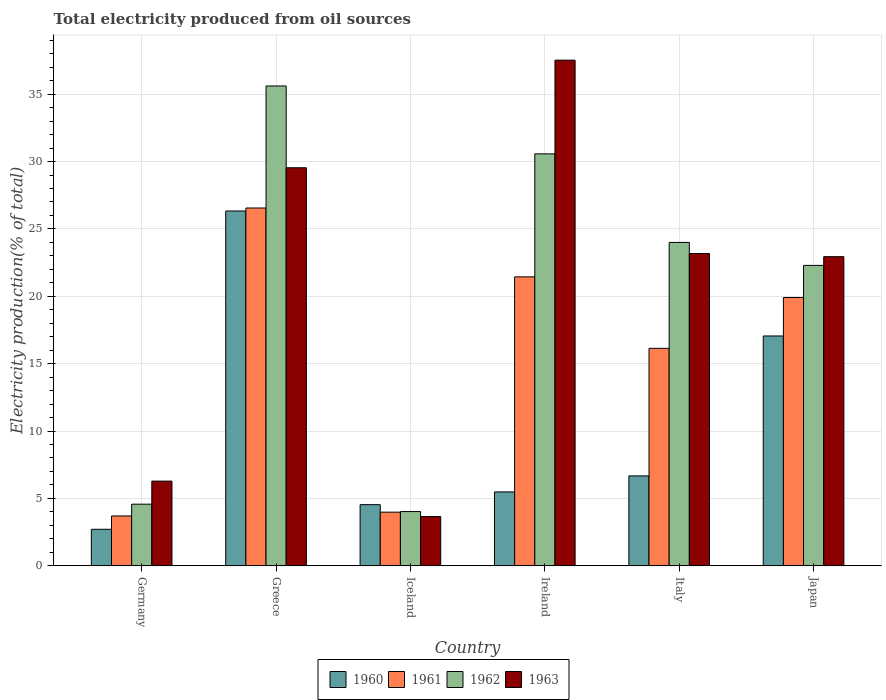How many different coloured bars are there?
Offer a very short reply. 4. How many bars are there on the 4th tick from the left?
Offer a very short reply. 4. How many bars are there on the 5th tick from the right?
Offer a very short reply. 4. What is the total electricity produced in 1960 in Italy?
Give a very brief answer. 6.67. Across all countries, what is the maximum total electricity produced in 1963?
Your answer should be very brief. 37.53. Across all countries, what is the minimum total electricity produced in 1962?
Make the answer very short. 4.03. In which country was the total electricity produced in 1963 maximum?
Provide a succinct answer. Ireland. In which country was the total electricity produced in 1961 minimum?
Offer a terse response. Germany. What is the total total electricity produced in 1960 in the graph?
Offer a terse response. 62.79. What is the difference between the total electricity produced in 1961 in Ireland and that in Italy?
Your answer should be compact. 5.3. What is the difference between the total electricity produced in 1962 in Japan and the total electricity produced in 1963 in Greece?
Ensure brevity in your answer.  -7.25. What is the average total electricity produced in 1962 per country?
Your answer should be compact. 20.18. What is the difference between the total electricity produced of/in 1960 and total electricity produced of/in 1961 in Iceland?
Ensure brevity in your answer.  0.56. In how many countries, is the total electricity produced in 1961 greater than 15 %?
Offer a terse response. 4. What is the ratio of the total electricity produced in 1961 in Greece to that in Iceland?
Give a very brief answer. 6.67. Is the total electricity produced in 1960 in Germany less than that in Iceland?
Offer a very short reply. Yes. Is the difference between the total electricity produced in 1960 in Ireland and Italy greater than the difference between the total electricity produced in 1961 in Ireland and Italy?
Your answer should be very brief. No. What is the difference between the highest and the second highest total electricity produced in 1961?
Your answer should be very brief. 6.64. What is the difference between the highest and the lowest total electricity produced in 1960?
Your answer should be compact. 23.62. What does the 1st bar from the right in Greece represents?
Keep it short and to the point. 1963. Is it the case that in every country, the sum of the total electricity produced in 1960 and total electricity produced in 1961 is greater than the total electricity produced in 1963?
Offer a terse response. No. How many bars are there?
Give a very brief answer. 24. Are all the bars in the graph horizontal?
Make the answer very short. No. Are the values on the major ticks of Y-axis written in scientific E-notation?
Your answer should be compact. No. Does the graph contain any zero values?
Your response must be concise. No. Where does the legend appear in the graph?
Offer a terse response. Bottom center. How many legend labels are there?
Your response must be concise. 4. How are the legend labels stacked?
Your answer should be very brief. Horizontal. What is the title of the graph?
Offer a terse response. Total electricity produced from oil sources. Does "1994" appear as one of the legend labels in the graph?
Offer a very short reply. No. What is the label or title of the X-axis?
Your response must be concise. Country. What is the label or title of the Y-axis?
Your answer should be compact. Electricity production(% of total). What is the Electricity production(% of total) in 1960 in Germany?
Your answer should be compact. 2.71. What is the Electricity production(% of total) in 1961 in Germany?
Provide a short and direct response. 3.7. What is the Electricity production(% of total) in 1962 in Germany?
Offer a very short reply. 4.57. What is the Electricity production(% of total) in 1963 in Germany?
Your answer should be compact. 6.28. What is the Electricity production(% of total) in 1960 in Greece?
Provide a succinct answer. 26.33. What is the Electricity production(% of total) in 1961 in Greece?
Provide a succinct answer. 26.55. What is the Electricity production(% of total) in 1962 in Greece?
Ensure brevity in your answer.  35.61. What is the Electricity production(% of total) of 1963 in Greece?
Offer a terse response. 29.54. What is the Electricity production(% of total) in 1960 in Iceland?
Give a very brief answer. 4.54. What is the Electricity production(% of total) in 1961 in Iceland?
Provide a succinct answer. 3.98. What is the Electricity production(% of total) in 1962 in Iceland?
Provide a succinct answer. 4.03. What is the Electricity production(% of total) in 1963 in Iceland?
Give a very brief answer. 3.66. What is the Electricity production(% of total) of 1960 in Ireland?
Your response must be concise. 5.48. What is the Electricity production(% of total) in 1961 in Ireland?
Your answer should be compact. 21.44. What is the Electricity production(% of total) of 1962 in Ireland?
Make the answer very short. 30.57. What is the Electricity production(% of total) of 1963 in Ireland?
Offer a very short reply. 37.53. What is the Electricity production(% of total) in 1960 in Italy?
Keep it short and to the point. 6.67. What is the Electricity production(% of total) in 1961 in Italy?
Provide a succinct answer. 16.14. What is the Electricity production(% of total) in 1962 in Italy?
Provide a succinct answer. 24. What is the Electricity production(% of total) in 1963 in Italy?
Your answer should be compact. 23.17. What is the Electricity production(% of total) of 1960 in Japan?
Give a very brief answer. 17.06. What is the Electricity production(% of total) of 1961 in Japan?
Offer a terse response. 19.91. What is the Electricity production(% of total) in 1962 in Japan?
Offer a very short reply. 22.29. What is the Electricity production(% of total) in 1963 in Japan?
Your response must be concise. 22.94. Across all countries, what is the maximum Electricity production(% of total) of 1960?
Provide a succinct answer. 26.33. Across all countries, what is the maximum Electricity production(% of total) in 1961?
Your answer should be very brief. 26.55. Across all countries, what is the maximum Electricity production(% of total) in 1962?
Your answer should be compact. 35.61. Across all countries, what is the maximum Electricity production(% of total) of 1963?
Provide a short and direct response. 37.53. Across all countries, what is the minimum Electricity production(% of total) of 1960?
Your answer should be compact. 2.71. Across all countries, what is the minimum Electricity production(% of total) of 1961?
Offer a very short reply. 3.7. Across all countries, what is the minimum Electricity production(% of total) in 1962?
Your response must be concise. 4.03. Across all countries, what is the minimum Electricity production(% of total) in 1963?
Your answer should be compact. 3.66. What is the total Electricity production(% of total) in 1960 in the graph?
Your response must be concise. 62.79. What is the total Electricity production(% of total) of 1961 in the graph?
Provide a succinct answer. 91.72. What is the total Electricity production(% of total) in 1962 in the graph?
Offer a very short reply. 121.07. What is the total Electricity production(% of total) of 1963 in the graph?
Ensure brevity in your answer.  123.13. What is the difference between the Electricity production(% of total) in 1960 in Germany and that in Greece?
Keep it short and to the point. -23.62. What is the difference between the Electricity production(% of total) in 1961 in Germany and that in Greece?
Offer a terse response. -22.86. What is the difference between the Electricity production(% of total) in 1962 in Germany and that in Greece?
Offer a very short reply. -31.04. What is the difference between the Electricity production(% of total) of 1963 in Germany and that in Greece?
Your answer should be compact. -23.26. What is the difference between the Electricity production(% of total) of 1960 in Germany and that in Iceland?
Provide a succinct answer. -1.83. What is the difference between the Electricity production(% of total) in 1961 in Germany and that in Iceland?
Your answer should be very brief. -0.28. What is the difference between the Electricity production(% of total) in 1962 in Germany and that in Iceland?
Your answer should be compact. 0.55. What is the difference between the Electricity production(% of total) of 1963 in Germany and that in Iceland?
Offer a very short reply. 2.63. What is the difference between the Electricity production(% of total) in 1960 in Germany and that in Ireland?
Your response must be concise. -2.77. What is the difference between the Electricity production(% of total) of 1961 in Germany and that in Ireland?
Offer a terse response. -17.75. What is the difference between the Electricity production(% of total) in 1962 in Germany and that in Ireland?
Offer a very short reply. -26. What is the difference between the Electricity production(% of total) in 1963 in Germany and that in Ireland?
Keep it short and to the point. -31.24. What is the difference between the Electricity production(% of total) in 1960 in Germany and that in Italy?
Provide a succinct answer. -3.96. What is the difference between the Electricity production(% of total) of 1961 in Germany and that in Italy?
Offer a very short reply. -12.44. What is the difference between the Electricity production(% of total) of 1962 in Germany and that in Italy?
Keep it short and to the point. -19.43. What is the difference between the Electricity production(% of total) of 1963 in Germany and that in Italy?
Ensure brevity in your answer.  -16.89. What is the difference between the Electricity production(% of total) of 1960 in Germany and that in Japan?
Give a very brief answer. -14.35. What is the difference between the Electricity production(% of total) in 1961 in Germany and that in Japan?
Provide a succinct answer. -16.21. What is the difference between the Electricity production(% of total) in 1962 in Germany and that in Japan?
Provide a succinct answer. -17.72. What is the difference between the Electricity production(% of total) in 1963 in Germany and that in Japan?
Your answer should be very brief. -16.66. What is the difference between the Electricity production(% of total) in 1960 in Greece and that in Iceland?
Offer a very short reply. 21.79. What is the difference between the Electricity production(% of total) in 1961 in Greece and that in Iceland?
Your answer should be very brief. 22.57. What is the difference between the Electricity production(% of total) in 1962 in Greece and that in Iceland?
Provide a short and direct response. 31.58. What is the difference between the Electricity production(% of total) in 1963 in Greece and that in Iceland?
Provide a short and direct response. 25.88. What is the difference between the Electricity production(% of total) of 1960 in Greece and that in Ireland?
Ensure brevity in your answer.  20.85. What is the difference between the Electricity production(% of total) of 1961 in Greece and that in Ireland?
Offer a very short reply. 5.11. What is the difference between the Electricity production(% of total) of 1962 in Greece and that in Ireland?
Ensure brevity in your answer.  5.04. What is the difference between the Electricity production(% of total) of 1963 in Greece and that in Ireland?
Offer a very short reply. -7.99. What is the difference between the Electricity production(% of total) of 1960 in Greece and that in Italy?
Your answer should be compact. 19.66. What is the difference between the Electricity production(% of total) in 1961 in Greece and that in Italy?
Your response must be concise. 10.42. What is the difference between the Electricity production(% of total) of 1962 in Greece and that in Italy?
Your response must be concise. 11.61. What is the difference between the Electricity production(% of total) in 1963 in Greece and that in Italy?
Make the answer very short. 6.37. What is the difference between the Electricity production(% of total) in 1960 in Greece and that in Japan?
Your answer should be very brief. 9.28. What is the difference between the Electricity production(% of total) of 1961 in Greece and that in Japan?
Give a very brief answer. 6.64. What is the difference between the Electricity production(% of total) of 1962 in Greece and that in Japan?
Your answer should be compact. 13.32. What is the difference between the Electricity production(% of total) of 1963 in Greece and that in Japan?
Ensure brevity in your answer.  6.6. What is the difference between the Electricity production(% of total) in 1960 in Iceland and that in Ireland?
Provide a short and direct response. -0.94. What is the difference between the Electricity production(% of total) of 1961 in Iceland and that in Ireland?
Keep it short and to the point. -17.46. What is the difference between the Electricity production(% of total) in 1962 in Iceland and that in Ireland?
Ensure brevity in your answer.  -26.55. What is the difference between the Electricity production(% of total) in 1963 in Iceland and that in Ireland?
Ensure brevity in your answer.  -33.87. What is the difference between the Electricity production(% of total) in 1960 in Iceland and that in Italy?
Make the answer very short. -2.13. What is the difference between the Electricity production(% of total) in 1961 in Iceland and that in Italy?
Your response must be concise. -12.16. What is the difference between the Electricity production(% of total) of 1962 in Iceland and that in Italy?
Your response must be concise. -19.97. What is the difference between the Electricity production(% of total) of 1963 in Iceland and that in Italy?
Keep it short and to the point. -19.52. What is the difference between the Electricity production(% of total) in 1960 in Iceland and that in Japan?
Make the answer very short. -12.52. What is the difference between the Electricity production(% of total) of 1961 in Iceland and that in Japan?
Provide a succinct answer. -15.93. What is the difference between the Electricity production(% of total) of 1962 in Iceland and that in Japan?
Provide a short and direct response. -18.27. What is the difference between the Electricity production(% of total) in 1963 in Iceland and that in Japan?
Give a very brief answer. -19.28. What is the difference between the Electricity production(% of total) in 1960 in Ireland and that in Italy?
Provide a succinct answer. -1.19. What is the difference between the Electricity production(% of total) in 1961 in Ireland and that in Italy?
Keep it short and to the point. 5.3. What is the difference between the Electricity production(% of total) of 1962 in Ireland and that in Italy?
Offer a very short reply. 6.57. What is the difference between the Electricity production(% of total) in 1963 in Ireland and that in Italy?
Provide a short and direct response. 14.35. What is the difference between the Electricity production(% of total) in 1960 in Ireland and that in Japan?
Offer a terse response. -11.57. What is the difference between the Electricity production(% of total) in 1961 in Ireland and that in Japan?
Your response must be concise. 1.53. What is the difference between the Electricity production(% of total) of 1962 in Ireland and that in Japan?
Ensure brevity in your answer.  8.28. What is the difference between the Electricity production(% of total) in 1963 in Ireland and that in Japan?
Offer a terse response. 14.58. What is the difference between the Electricity production(% of total) in 1960 in Italy and that in Japan?
Your answer should be very brief. -10.39. What is the difference between the Electricity production(% of total) of 1961 in Italy and that in Japan?
Ensure brevity in your answer.  -3.77. What is the difference between the Electricity production(% of total) of 1962 in Italy and that in Japan?
Keep it short and to the point. 1.71. What is the difference between the Electricity production(% of total) in 1963 in Italy and that in Japan?
Offer a terse response. 0.23. What is the difference between the Electricity production(% of total) of 1960 in Germany and the Electricity production(% of total) of 1961 in Greece?
Offer a very short reply. -23.85. What is the difference between the Electricity production(% of total) in 1960 in Germany and the Electricity production(% of total) in 1962 in Greece?
Offer a terse response. -32.9. What is the difference between the Electricity production(% of total) in 1960 in Germany and the Electricity production(% of total) in 1963 in Greece?
Give a very brief answer. -26.83. What is the difference between the Electricity production(% of total) of 1961 in Germany and the Electricity production(% of total) of 1962 in Greece?
Provide a succinct answer. -31.91. What is the difference between the Electricity production(% of total) of 1961 in Germany and the Electricity production(% of total) of 1963 in Greece?
Give a very brief answer. -25.84. What is the difference between the Electricity production(% of total) of 1962 in Germany and the Electricity production(% of total) of 1963 in Greece?
Offer a very short reply. -24.97. What is the difference between the Electricity production(% of total) in 1960 in Germany and the Electricity production(% of total) in 1961 in Iceland?
Ensure brevity in your answer.  -1.27. What is the difference between the Electricity production(% of total) in 1960 in Germany and the Electricity production(% of total) in 1962 in Iceland?
Your answer should be compact. -1.32. What is the difference between the Electricity production(% of total) in 1960 in Germany and the Electricity production(% of total) in 1963 in Iceland?
Your response must be concise. -0.95. What is the difference between the Electricity production(% of total) of 1961 in Germany and the Electricity production(% of total) of 1962 in Iceland?
Offer a terse response. -0.33. What is the difference between the Electricity production(% of total) in 1961 in Germany and the Electricity production(% of total) in 1963 in Iceland?
Your answer should be compact. 0.04. What is the difference between the Electricity production(% of total) in 1962 in Germany and the Electricity production(% of total) in 1963 in Iceland?
Provide a succinct answer. 0.91. What is the difference between the Electricity production(% of total) of 1960 in Germany and the Electricity production(% of total) of 1961 in Ireland?
Ensure brevity in your answer.  -18.73. What is the difference between the Electricity production(% of total) in 1960 in Germany and the Electricity production(% of total) in 1962 in Ireland?
Provide a short and direct response. -27.86. What is the difference between the Electricity production(% of total) in 1960 in Germany and the Electricity production(% of total) in 1963 in Ireland?
Your response must be concise. -34.82. What is the difference between the Electricity production(% of total) of 1961 in Germany and the Electricity production(% of total) of 1962 in Ireland?
Your response must be concise. -26.87. What is the difference between the Electricity production(% of total) in 1961 in Germany and the Electricity production(% of total) in 1963 in Ireland?
Make the answer very short. -33.83. What is the difference between the Electricity production(% of total) of 1962 in Germany and the Electricity production(% of total) of 1963 in Ireland?
Keep it short and to the point. -32.95. What is the difference between the Electricity production(% of total) of 1960 in Germany and the Electricity production(% of total) of 1961 in Italy?
Provide a short and direct response. -13.43. What is the difference between the Electricity production(% of total) in 1960 in Germany and the Electricity production(% of total) in 1962 in Italy?
Offer a very short reply. -21.29. What is the difference between the Electricity production(% of total) in 1960 in Germany and the Electricity production(% of total) in 1963 in Italy?
Provide a short and direct response. -20.47. What is the difference between the Electricity production(% of total) of 1961 in Germany and the Electricity production(% of total) of 1962 in Italy?
Your answer should be very brief. -20.3. What is the difference between the Electricity production(% of total) of 1961 in Germany and the Electricity production(% of total) of 1963 in Italy?
Provide a short and direct response. -19.48. What is the difference between the Electricity production(% of total) in 1962 in Germany and the Electricity production(% of total) in 1963 in Italy?
Your response must be concise. -18.6. What is the difference between the Electricity production(% of total) of 1960 in Germany and the Electricity production(% of total) of 1961 in Japan?
Give a very brief answer. -17.2. What is the difference between the Electricity production(% of total) of 1960 in Germany and the Electricity production(% of total) of 1962 in Japan?
Your answer should be very brief. -19.58. What is the difference between the Electricity production(% of total) of 1960 in Germany and the Electricity production(% of total) of 1963 in Japan?
Offer a very short reply. -20.23. What is the difference between the Electricity production(% of total) in 1961 in Germany and the Electricity production(% of total) in 1962 in Japan?
Your answer should be very brief. -18.6. What is the difference between the Electricity production(% of total) in 1961 in Germany and the Electricity production(% of total) in 1963 in Japan?
Your response must be concise. -19.24. What is the difference between the Electricity production(% of total) in 1962 in Germany and the Electricity production(% of total) in 1963 in Japan?
Offer a very short reply. -18.37. What is the difference between the Electricity production(% of total) in 1960 in Greece and the Electricity production(% of total) in 1961 in Iceland?
Ensure brevity in your answer.  22.35. What is the difference between the Electricity production(% of total) in 1960 in Greece and the Electricity production(% of total) in 1962 in Iceland?
Your answer should be very brief. 22.31. What is the difference between the Electricity production(% of total) in 1960 in Greece and the Electricity production(% of total) in 1963 in Iceland?
Make the answer very short. 22.67. What is the difference between the Electricity production(% of total) in 1961 in Greece and the Electricity production(% of total) in 1962 in Iceland?
Keep it short and to the point. 22.53. What is the difference between the Electricity production(% of total) in 1961 in Greece and the Electricity production(% of total) in 1963 in Iceland?
Provide a short and direct response. 22.9. What is the difference between the Electricity production(% of total) in 1962 in Greece and the Electricity production(% of total) in 1963 in Iceland?
Your answer should be compact. 31.95. What is the difference between the Electricity production(% of total) of 1960 in Greece and the Electricity production(% of total) of 1961 in Ireland?
Offer a terse response. 4.89. What is the difference between the Electricity production(% of total) of 1960 in Greece and the Electricity production(% of total) of 1962 in Ireland?
Your answer should be compact. -4.24. What is the difference between the Electricity production(% of total) of 1960 in Greece and the Electricity production(% of total) of 1963 in Ireland?
Give a very brief answer. -11.19. What is the difference between the Electricity production(% of total) of 1961 in Greece and the Electricity production(% of total) of 1962 in Ireland?
Ensure brevity in your answer.  -4.02. What is the difference between the Electricity production(% of total) in 1961 in Greece and the Electricity production(% of total) in 1963 in Ireland?
Your answer should be very brief. -10.97. What is the difference between the Electricity production(% of total) in 1962 in Greece and the Electricity production(% of total) in 1963 in Ireland?
Your answer should be compact. -1.92. What is the difference between the Electricity production(% of total) in 1960 in Greece and the Electricity production(% of total) in 1961 in Italy?
Ensure brevity in your answer.  10.19. What is the difference between the Electricity production(% of total) in 1960 in Greece and the Electricity production(% of total) in 1962 in Italy?
Give a very brief answer. 2.33. What is the difference between the Electricity production(% of total) in 1960 in Greece and the Electricity production(% of total) in 1963 in Italy?
Keep it short and to the point. 3.16. What is the difference between the Electricity production(% of total) of 1961 in Greece and the Electricity production(% of total) of 1962 in Italy?
Offer a terse response. 2.55. What is the difference between the Electricity production(% of total) in 1961 in Greece and the Electricity production(% of total) in 1963 in Italy?
Your answer should be compact. 3.38. What is the difference between the Electricity production(% of total) of 1962 in Greece and the Electricity production(% of total) of 1963 in Italy?
Your answer should be compact. 12.44. What is the difference between the Electricity production(% of total) in 1960 in Greece and the Electricity production(% of total) in 1961 in Japan?
Ensure brevity in your answer.  6.42. What is the difference between the Electricity production(% of total) in 1960 in Greece and the Electricity production(% of total) in 1962 in Japan?
Make the answer very short. 4.04. What is the difference between the Electricity production(% of total) of 1960 in Greece and the Electricity production(% of total) of 1963 in Japan?
Make the answer very short. 3.39. What is the difference between the Electricity production(% of total) of 1961 in Greece and the Electricity production(% of total) of 1962 in Japan?
Provide a short and direct response. 4.26. What is the difference between the Electricity production(% of total) of 1961 in Greece and the Electricity production(% of total) of 1963 in Japan?
Your answer should be very brief. 3.61. What is the difference between the Electricity production(% of total) in 1962 in Greece and the Electricity production(% of total) in 1963 in Japan?
Ensure brevity in your answer.  12.67. What is the difference between the Electricity production(% of total) of 1960 in Iceland and the Electricity production(% of total) of 1961 in Ireland?
Provide a succinct answer. -16.91. What is the difference between the Electricity production(% of total) of 1960 in Iceland and the Electricity production(% of total) of 1962 in Ireland?
Keep it short and to the point. -26.03. What is the difference between the Electricity production(% of total) of 1960 in Iceland and the Electricity production(% of total) of 1963 in Ireland?
Provide a short and direct response. -32.99. What is the difference between the Electricity production(% of total) of 1961 in Iceland and the Electricity production(% of total) of 1962 in Ireland?
Provide a short and direct response. -26.59. What is the difference between the Electricity production(% of total) in 1961 in Iceland and the Electricity production(% of total) in 1963 in Ireland?
Offer a terse response. -33.55. What is the difference between the Electricity production(% of total) in 1962 in Iceland and the Electricity production(% of total) in 1963 in Ireland?
Your answer should be very brief. -33.5. What is the difference between the Electricity production(% of total) in 1960 in Iceland and the Electricity production(% of total) in 1961 in Italy?
Offer a very short reply. -11.6. What is the difference between the Electricity production(% of total) in 1960 in Iceland and the Electricity production(% of total) in 1962 in Italy?
Keep it short and to the point. -19.46. What is the difference between the Electricity production(% of total) of 1960 in Iceland and the Electricity production(% of total) of 1963 in Italy?
Offer a terse response. -18.64. What is the difference between the Electricity production(% of total) of 1961 in Iceland and the Electricity production(% of total) of 1962 in Italy?
Provide a succinct answer. -20.02. What is the difference between the Electricity production(% of total) of 1961 in Iceland and the Electricity production(% of total) of 1963 in Italy?
Offer a terse response. -19.19. What is the difference between the Electricity production(% of total) of 1962 in Iceland and the Electricity production(% of total) of 1963 in Italy?
Make the answer very short. -19.15. What is the difference between the Electricity production(% of total) in 1960 in Iceland and the Electricity production(% of total) in 1961 in Japan?
Provide a short and direct response. -15.37. What is the difference between the Electricity production(% of total) in 1960 in Iceland and the Electricity production(% of total) in 1962 in Japan?
Ensure brevity in your answer.  -17.76. What is the difference between the Electricity production(% of total) in 1960 in Iceland and the Electricity production(% of total) in 1963 in Japan?
Provide a short and direct response. -18.4. What is the difference between the Electricity production(% of total) in 1961 in Iceland and the Electricity production(% of total) in 1962 in Japan?
Your answer should be very brief. -18.31. What is the difference between the Electricity production(% of total) in 1961 in Iceland and the Electricity production(% of total) in 1963 in Japan?
Offer a very short reply. -18.96. What is the difference between the Electricity production(% of total) in 1962 in Iceland and the Electricity production(% of total) in 1963 in Japan?
Your answer should be very brief. -18.92. What is the difference between the Electricity production(% of total) in 1960 in Ireland and the Electricity production(% of total) in 1961 in Italy?
Your answer should be very brief. -10.66. What is the difference between the Electricity production(% of total) in 1960 in Ireland and the Electricity production(% of total) in 1962 in Italy?
Offer a terse response. -18.52. What is the difference between the Electricity production(% of total) in 1960 in Ireland and the Electricity production(% of total) in 1963 in Italy?
Provide a short and direct response. -17.69. What is the difference between the Electricity production(% of total) of 1961 in Ireland and the Electricity production(% of total) of 1962 in Italy?
Provide a short and direct response. -2.56. What is the difference between the Electricity production(% of total) in 1961 in Ireland and the Electricity production(% of total) in 1963 in Italy?
Offer a terse response. -1.73. What is the difference between the Electricity production(% of total) of 1962 in Ireland and the Electricity production(% of total) of 1963 in Italy?
Provide a short and direct response. 7.4. What is the difference between the Electricity production(% of total) in 1960 in Ireland and the Electricity production(% of total) in 1961 in Japan?
Offer a very short reply. -14.43. What is the difference between the Electricity production(% of total) of 1960 in Ireland and the Electricity production(% of total) of 1962 in Japan?
Your answer should be very brief. -16.81. What is the difference between the Electricity production(% of total) of 1960 in Ireland and the Electricity production(% of total) of 1963 in Japan?
Make the answer very short. -17.46. What is the difference between the Electricity production(% of total) of 1961 in Ireland and the Electricity production(% of total) of 1962 in Japan?
Give a very brief answer. -0.85. What is the difference between the Electricity production(% of total) of 1961 in Ireland and the Electricity production(% of total) of 1963 in Japan?
Your answer should be very brief. -1.5. What is the difference between the Electricity production(% of total) of 1962 in Ireland and the Electricity production(% of total) of 1963 in Japan?
Your answer should be compact. 7.63. What is the difference between the Electricity production(% of total) in 1960 in Italy and the Electricity production(% of total) in 1961 in Japan?
Give a very brief answer. -13.24. What is the difference between the Electricity production(% of total) of 1960 in Italy and the Electricity production(% of total) of 1962 in Japan?
Your response must be concise. -15.62. What is the difference between the Electricity production(% of total) of 1960 in Italy and the Electricity production(% of total) of 1963 in Japan?
Make the answer very short. -16.27. What is the difference between the Electricity production(% of total) in 1961 in Italy and the Electricity production(% of total) in 1962 in Japan?
Give a very brief answer. -6.15. What is the difference between the Electricity production(% of total) in 1961 in Italy and the Electricity production(% of total) in 1963 in Japan?
Offer a terse response. -6.8. What is the difference between the Electricity production(% of total) in 1962 in Italy and the Electricity production(% of total) in 1963 in Japan?
Keep it short and to the point. 1.06. What is the average Electricity production(% of total) of 1960 per country?
Provide a succinct answer. 10.46. What is the average Electricity production(% of total) of 1961 per country?
Provide a succinct answer. 15.29. What is the average Electricity production(% of total) in 1962 per country?
Ensure brevity in your answer.  20.18. What is the average Electricity production(% of total) of 1963 per country?
Your answer should be compact. 20.52. What is the difference between the Electricity production(% of total) in 1960 and Electricity production(% of total) in 1961 in Germany?
Offer a very short reply. -0.99. What is the difference between the Electricity production(% of total) in 1960 and Electricity production(% of total) in 1962 in Germany?
Give a very brief answer. -1.86. What is the difference between the Electricity production(% of total) in 1960 and Electricity production(% of total) in 1963 in Germany?
Make the answer very short. -3.58. What is the difference between the Electricity production(% of total) in 1961 and Electricity production(% of total) in 1962 in Germany?
Your answer should be compact. -0.87. What is the difference between the Electricity production(% of total) in 1961 and Electricity production(% of total) in 1963 in Germany?
Provide a succinct answer. -2.59. What is the difference between the Electricity production(% of total) of 1962 and Electricity production(% of total) of 1963 in Germany?
Offer a terse response. -1.71. What is the difference between the Electricity production(% of total) of 1960 and Electricity production(% of total) of 1961 in Greece?
Make the answer very short. -0.22. What is the difference between the Electricity production(% of total) in 1960 and Electricity production(% of total) in 1962 in Greece?
Offer a very short reply. -9.28. What is the difference between the Electricity production(% of total) in 1960 and Electricity production(% of total) in 1963 in Greece?
Ensure brevity in your answer.  -3.21. What is the difference between the Electricity production(% of total) in 1961 and Electricity production(% of total) in 1962 in Greece?
Provide a succinct answer. -9.06. What is the difference between the Electricity production(% of total) of 1961 and Electricity production(% of total) of 1963 in Greece?
Provide a succinct answer. -2.99. What is the difference between the Electricity production(% of total) in 1962 and Electricity production(% of total) in 1963 in Greece?
Your answer should be very brief. 6.07. What is the difference between the Electricity production(% of total) in 1960 and Electricity production(% of total) in 1961 in Iceland?
Your response must be concise. 0.56. What is the difference between the Electricity production(% of total) in 1960 and Electricity production(% of total) in 1962 in Iceland?
Your answer should be very brief. 0.51. What is the difference between the Electricity production(% of total) of 1960 and Electricity production(% of total) of 1963 in Iceland?
Offer a very short reply. 0.88. What is the difference between the Electricity production(% of total) in 1961 and Electricity production(% of total) in 1962 in Iceland?
Offer a terse response. -0.05. What is the difference between the Electricity production(% of total) in 1961 and Electricity production(% of total) in 1963 in Iceland?
Your response must be concise. 0.32. What is the difference between the Electricity production(% of total) in 1962 and Electricity production(% of total) in 1963 in Iceland?
Your answer should be compact. 0.37. What is the difference between the Electricity production(% of total) in 1960 and Electricity production(% of total) in 1961 in Ireland?
Offer a terse response. -15.96. What is the difference between the Electricity production(% of total) in 1960 and Electricity production(% of total) in 1962 in Ireland?
Give a very brief answer. -25.09. What is the difference between the Electricity production(% of total) of 1960 and Electricity production(% of total) of 1963 in Ireland?
Your answer should be compact. -32.04. What is the difference between the Electricity production(% of total) in 1961 and Electricity production(% of total) in 1962 in Ireland?
Provide a succinct answer. -9.13. What is the difference between the Electricity production(% of total) in 1961 and Electricity production(% of total) in 1963 in Ireland?
Your answer should be compact. -16.08. What is the difference between the Electricity production(% of total) of 1962 and Electricity production(% of total) of 1963 in Ireland?
Provide a short and direct response. -6.95. What is the difference between the Electricity production(% of total) in 1960 and Electricity production(% of total) in 1961 in Italy?
Keep it short and to the point. -9.47. What is the difference between the Electricity production(% of total) of 1960 and Electricity production(% of total) of 1962 in Italy?
Your answer should be compact. -17.33. What is the difference between the Electricity production(% of total) in 1960 and Electricity production(% of total) in 1963 in Italy?
Offer a very short reply. -16.5. What is the difference between the Electricity production(% of total) of 1961 and Electricity production(% of total) of 1962 in Italy?
Ensure brevity in your answer.  -7.86. What is the difference between the Electricity production(% of total) of 1961 and Electricity production(% of total) of 1963 in Italy?
Provide a succinct answer. -7.04. What is the difference between the Electricity production(% of total) in 1962 and Electricity production(% of total) in 1963 in Italy?
Offer a terse response. 0.83. What is the difference between the Electricity production(% of total) of 1960 and Electricity production(% of total) of 1961 in Japan?
Make the answer very short. -2.85. What is the difference between the Electricity production(% of total) in 1960 and Electricity production(% of total) in 1962 in Japan?
Your response must be concise. -5.24. What is the difference between the Electricity production(% of total) of 1960 and Electricity production(% of total) of 1963 in Japan?
Make the answer very short. -5.89. What is the difference between the Electricity production(% of total) in 1961 and Electricity production(% of total) in 1962 in Japan?
Give a very brief answer. -2.38. What is the difference between the Electricity production(% of total) in 1961 and Electricity production(% of total) in 1963 in Japan?
Provide a succinct answer. -3.03. What is the difference between the Electricity production(% of total) in 1962 and Electricity production(% of total) in 1963 in Japan?
Offer a terse response. -0.65. What is the ratio of the Electricity production(% of total) in 1960 in Germany to that in Greece?
Your response must be concise. 0.1. What is the ratio of the Electricity production(% of total) of 1961 in Germany to that in Greece?
Offer a very short reply. 0.14. What is the ratio of the Electricity production(% of total) in 1962 in Germany to that in Greece?
Make the answer very short. 0.13. What is the ratio of the Electricity production(% of total) of 1963 in Germany to that in Greece?
Ensure brevity in your answer.  0.21. What is the ratio of the Electricity production(% of total) of 1960 in Germany to that in Iceland?
Provide a short and direct response. 0.6. What is the ratio of the Electricity production(% of total) of 1961 in Germany to that in Iceland?
Your answer should be very brief. 0.93. What is the ratio of the Electricity production(% of total) of 1962 in Germany to that in Iceland?
Provide a succinct answer. 1.14. What is the ratio of the Electricity production(% of total) of 1963 in Germany to that in Iceland?
Keep it short and to the point. 1.72. What is the ratio of the Electricity production(% of total) of 1960 in Germany to that in Ireland?
Your answer should be very brief. 0.49. What is the ratio of the Electricity production(% of total) in 1961 in Germany to that in Ireland?
Your answer should be compact. 0.17. What is the ratio of the Electricity production(% of total) of 1962 in Germany to that in Ireland?
Give a very brief answer. 0.15. What is the ratio of the Electricity production(% of total) of 1963 in Germany to that in Ireland?
Ensure brevity in your answer.  0.17. What is the ratio of the Electricity production(% of total) of 1960 in Germany to that in Italy?
Keep it short and to the point. 0.41. What is the ratio of the Electricity production(% of total) of 1961 in Germany to that in Italy?
Offer a very short reply. 0.23. What is the ratio of the Electricity production(% of total) in 1962 in Germany to that in Italy?
Offer a terse response. 0.19. What is the ratio of the Electricity production(% of total) in 1963 in Germany to that in Italy?
Offer a very short reply. 0.27. What is the ratio of the Electricity production(% of total) in 1960 in Germany to that in Japan?
Your answer should be compact. 0.16. What is the ratio of the Electricity production(% of total) of 1961 in Germany to that in Japan?
Make the answer very short. 0.19. What is the ratio of the Electricity production(% of total) in 1962 in Germany to that in Japan?
Offer a terse response. 0.21. What is the ratio of the Electricity production(% of total) in 1963 in Germany to that in Japan?
Offer a very short reply. 0.27. What is the ratio of the Electricity production(% of total) of 1960 in Greece to that in Iceland?
Provide a short and direct response. 5.8. What is the ratio of the Electricity production(% of total) of 1961 in Greece to that in Iceland?
Your answer should be very brief. 6.67. What is the ratio of the Electricity production(% of total) in 1962 in Greece to that in Iceland?
Your answer should be very brief. 8.85. What is the ratio of the Electricity production(% of total) of 1963 in Greece to that in Iceland?
Make the answer very short. 8.07. What is the ratio of the Electricity production(% of total) of 1960 in Greece to that in Ireland?
Provide a short and direct response. 4.8. What is the ratio of the Electricity production(% of total) of 1961 in Greece to that in Ireland?
Offer a very short reply. 1.24. What is the ratio of the Electricity production(% of total) of 1962 in Greece to that in Ireland?
Offer a very short reply. 1.16. What is the ratio of the Electricity production(% of total) in 1963 in Greece to that in Ireland?
Offer a very short reply. 0.79. What is the ratio of the Electricity production(% of total) in 1960 in Greece to that in Italy?
Your answer should be compact. 3.95. What is the ratio of the Electricity production(% of total) in 1961 in Greece to that in Italy?
Your response must be concise. 1.65. What is the ratio of the Electricity production(% of total) of 1962 in Greece to that in Italy?
Offer a very short reply. 1.48. What is the ratio of the Electricity production(% of total) in 1963 in Greece to that in Italy?
Give a very brief answer. 1.27. What is the ratio of the Electricity production(% of total) of 1960 in Greece to that in Japan?
Offer a terse response. 1.54. What is the ratio of the Electricity production(% of total) of 1961 in Greece to that in Japan?
Provide a short and direct response. 1.33. What is the ratio of the Electricity production(% of total) of 1962 in Greece to that in Japan?
Give a very brief answer. 1.6. What is the ratio of the Electricity production(% of total) of 1963 in Greece to that in Japan?
Keep it short and to the point. 1.29. What is the ratio of the Electricity production(% of total) of 1960 in Iceland to that in Ireland?
Give a very brief answer. 0.83. What is the ratio of the Electricity production(% of total) in 1961 in Iceland to that in Ireland?
Your answer should be compact. 0.19. What is the ratio of the Electricity production(% of total) of 1962 in Iceland to that in Ireland?
Your answer should be very brief. 0.13. What is the ratio of the Electricity production(% of total) of 1963 in Iceland to that in Ireland?
Make the answer very short. 0.1. What is the ratio of the Electricity production(% of total) in 1960 in Iceland to that in Italy?
Keep it short and to the point. 0.68. What is the ratio of the Electricity production(% of total) in 1961 in Iceland to that in Italy?
Ensure brevity in your answer.  0.25. What is the ratio of the Electricity production(% of total) of 1962 in Iceland to that in Italy?
Make the answer very short. 0.17. What is the ratio of the Electricity production(% of total) in 1963 in Iceland to that in Italy?
Your response must be concise. 0.16. What is the ratio of the Electricity production(% of total) of 1960 in Iceland to that in Japan?
Offer a very short reply. 0.27. What is the ratio of the Electricity production(% of total) of 1961 in Iceland to that in Japan?
Offer a terse response. 0.2. What is the ratio of the Electricity production(% of total) of 1962 in Iceland to that in Japan?
Give a very brief answer. 0.18. What is the ratio of the Electricity production(% of total) of 1963 in Iceland to that in Japan?
Offer a very short reply. 0.16. What is the ratio of the Electricity production(% of total) in 1960 in Ireland to that in Italy?
Your response must be concise. 0.82. What is the ratio of the Electricity production(% of total) in 1961 in Ireland to that in Italy?
Offer a very short reply. 1.33. What is the ratio of the Electricity production(% of total) in 1962 in Ireland to that in Italy?
Offer a very short reply. 1.27. What is the ratio of the Electricity production(% of total) of 1963 in Ireland to that in Italy?
Make the answer very short. 1.62. What is the ratio of the Electricity production(% of total) in 1960 in Ireland to that in Japan?
Give a very brief answer. 0.32. What is the ratio of the Electricity production(% of total) of 1961 in Ireland to that in Japan?
Provide a short and direct response. 1.08. What is the ratio of the Electricity production(% of total) in 1962 in Ireland to that in Japan?
Give a very brief answer. 1.37. What is the ratio of the Electricity production(% of total) of 1963 in Ireland to that in Japan?
Keep it short and to the point. 1.64. What is the ratio of the Electricity production(% of total) of 1960 in Italy to that in Japan?
Keep it short and to the point. 0.39. What is the ratio of the Electricity production(% of total) in 1961 in Italy to that in Japan?
Make the answer very short. 0.81. What is the ratio of the Electricity production(% of total) in 1962 in Italy to that in Japan?
Your response must be concise. 1.08. What is the difference between the highest and the second highest Electricity production(% of total) of 1960?
Give a very brief answer. 9.28. What is the difference between the highest and the second highest Electricity production(% of total) of 1961?
Provide a succinct answer. 5.11. What is the difference between the highest and the second highest Electricity production(% of total) in 1962?
Your answer should be compact. 5.04. What is the difference between the highest and the second highest Electricity production(% of total) in 1963?
Your answer should be very brief. 7.99. What is the difference between the highest and the lowest Electricity production(% of total) in 1960?
Provide a short and direct response. 23.62. What is the difference between the highest and the lowest Electricity production(% of total) in 1961?
Provide a succinct answer. 22.86. What is the difference between the highest and the lowest Electricity production(% of total) of 1962?
Ensure brevity in your answer.  31.58. What is the difference between the highest and the lowest Electricity production(% of total) of 1963?
Keep it short and to the point. 33.87. 